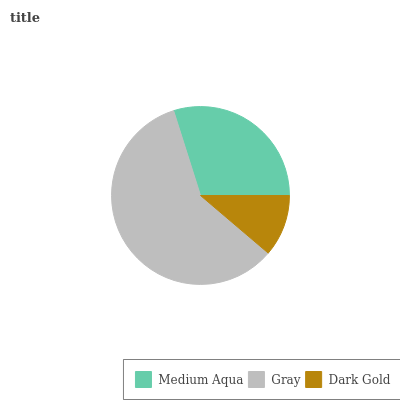Is Dark Gold the minimum?
Answer yes or no. Yes. Is Gray the maximum?
Answer yes or no. Yes. Is Gray the minimum?
Answer yes or no. No. Is Dark Gold the maximum?
Answer yes or no. No. Is Gray greater than Dark Gold?
Answer yes or no. Yes. Is Dark Gold less than Gray?
Answer yes or no. Yes. Is Dark Gold greater than Gray?
Answer yes or no. No. Is Gray less than Dark Gold?
Answer yes or no. No. Is Medium Aqua the high median?
Answer yes or no. Yes. Is Medium Aqua the low median?
Answer yes or no. Yes. Is Dark Gold the high median?
Answer yes or no. No. Is Gray the low median?
Answer yes or no. No. 